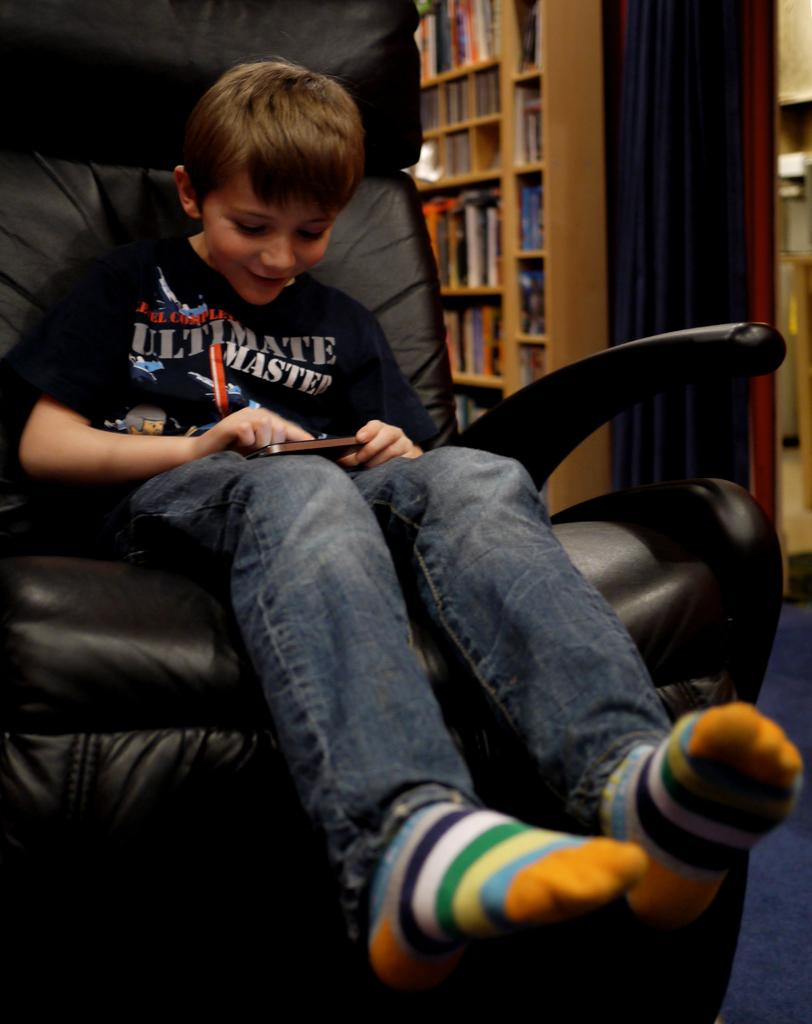What is the main subject of the image? The main subject of the image is a kid. What is the kid doing in the image? The kid is sitting on a chair in the image. What can be seen in the background of the image? There is a bookshelf in the image. What is on the bookshelf? Books are present on the bookshelf. What type of plane is flying over the kid in the image? There is no plane visible in the image; the main subject is a kid sitting on a chair. 